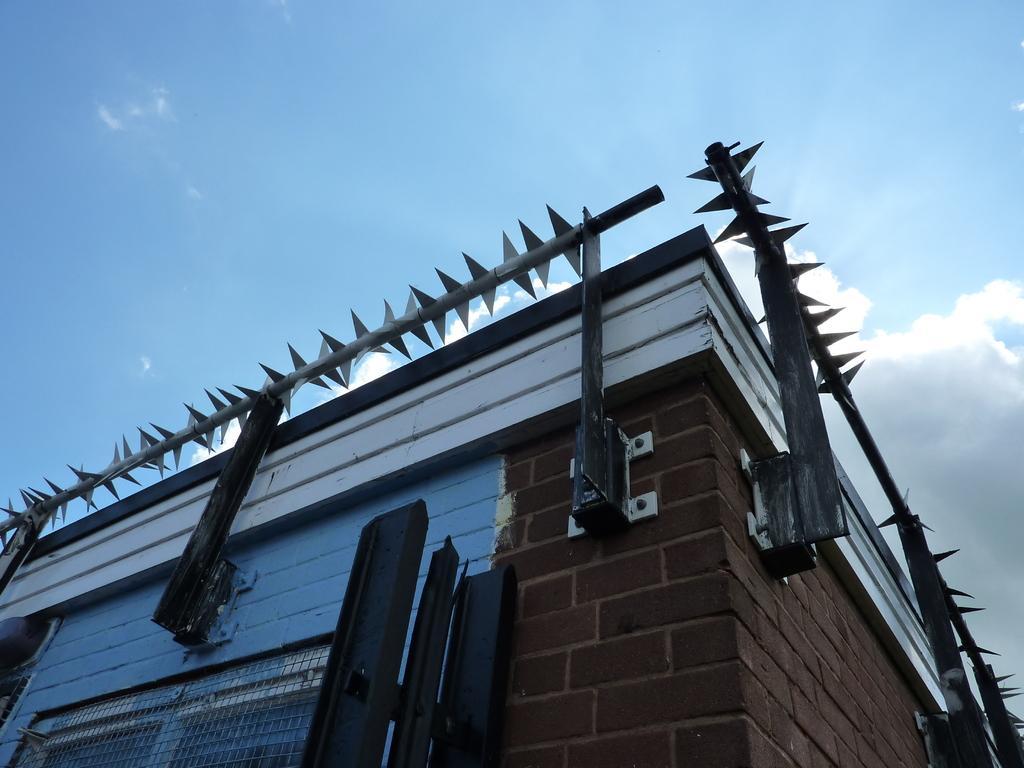Please provide a concise description of this image. In the image we can see building, metal fence and the cloudy sky. 